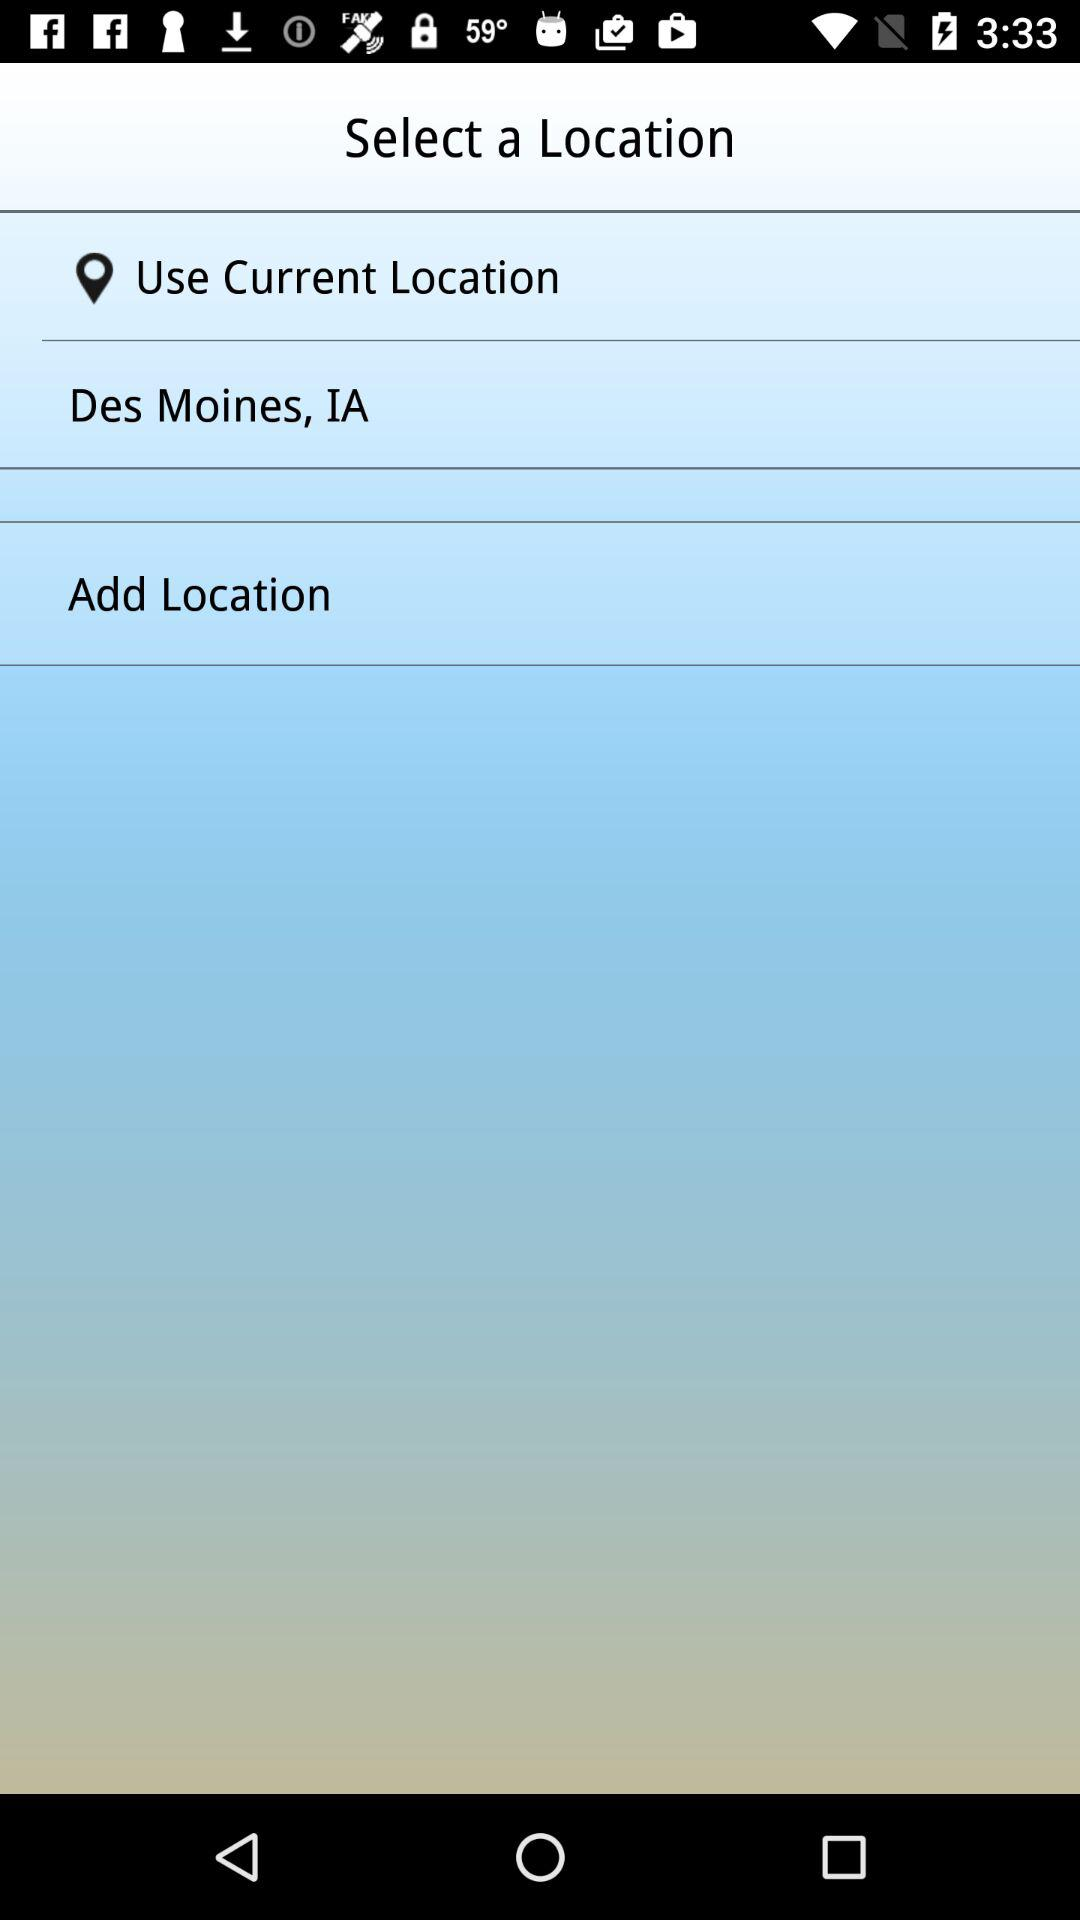What is the current location? The current location is Des Moines, IA. 